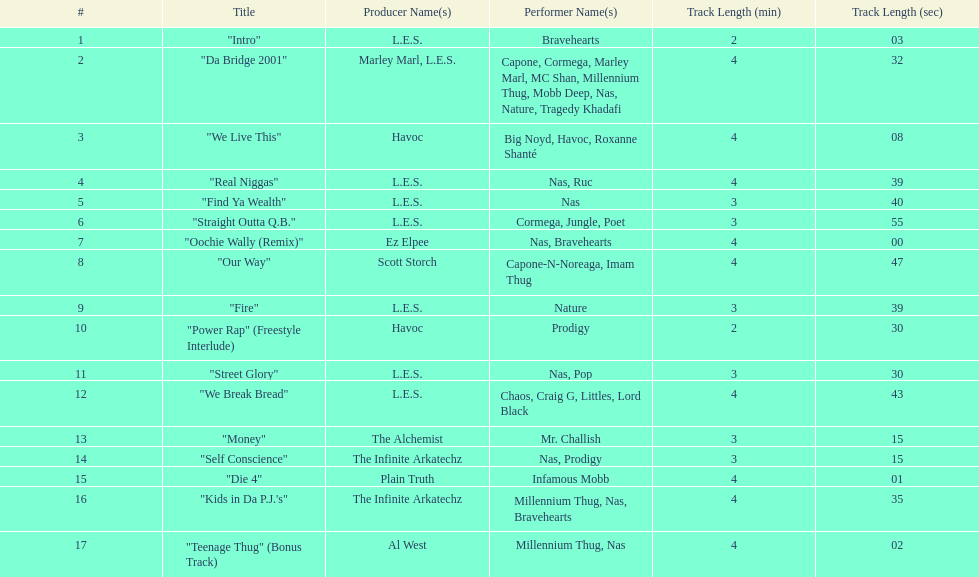How many songs were on the track list? 17. 